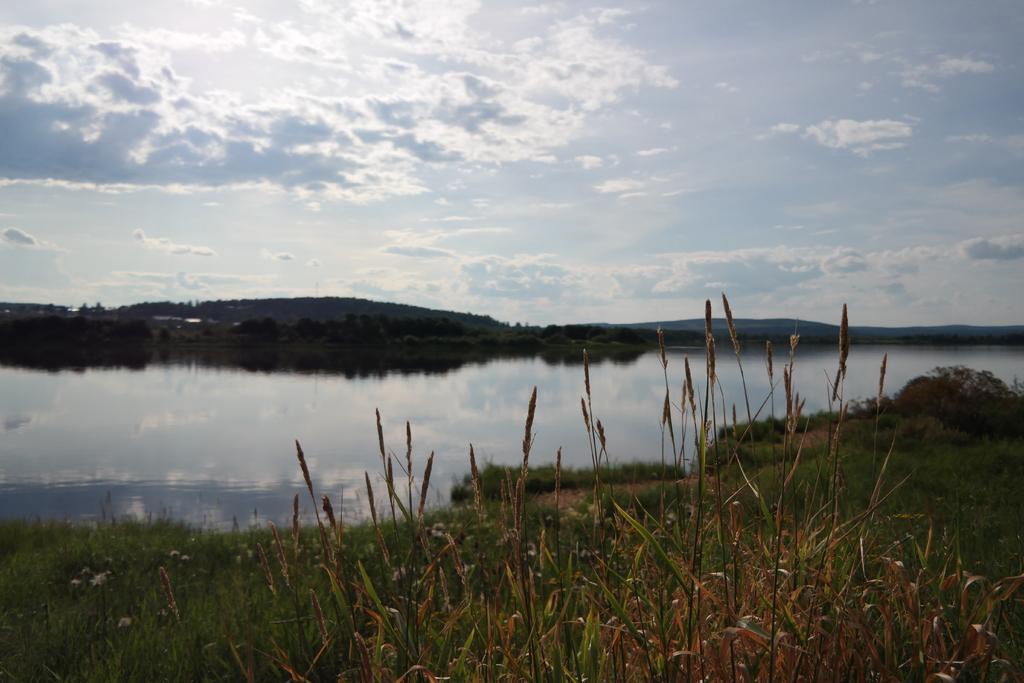Please provide a concise description of this image. In this picture there are few plants and a greenery ground and there is water in front of it and there are trees and mountains in the background and the sky is a bit cloudy. 